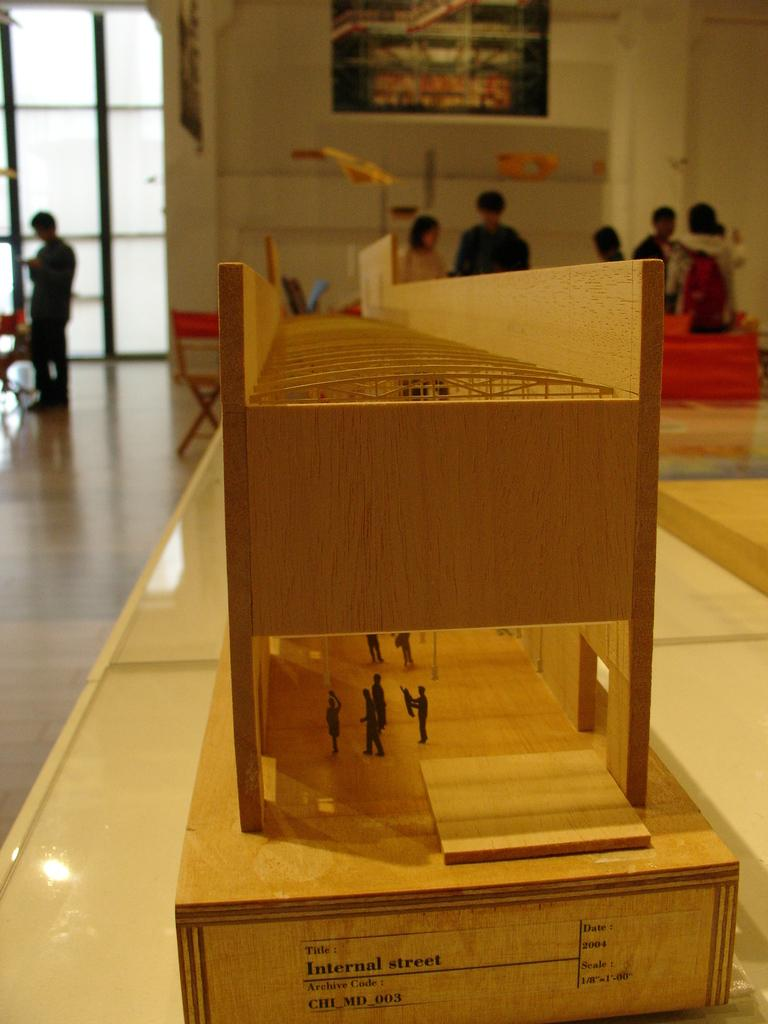What type of surface is visible in the image? There is a floor in the image. What piece of furniture can be seen in the image? There is a table in the image. What type of cooking appliance is present in the image? There is a wooden grill in the image. What surrounds the area in the image? There are walls in the image. What are the persons in the image doing? There are persons on the floor in the image. What type of milk is being served in the image? There is no milk present in the image. What type of polish is being applied to the wooden grill in the image? There is no polish or indication of polishing in the image. 